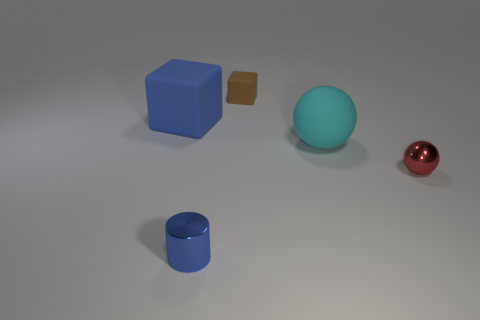Add 5 large purple shiny spheres. How many objects exist? 10 Subtract all balls. How many objects are left? 3 Subtract all blue objects. Subtract all large yellow blocks. How many objects are left? 3 Add 1 tiny objects. How many tiny objects are left? 4 Add 2 tiny yellow rubber balls. How many tiny yellow rubber balls exist? 2 Subtract 0 purple blocks. How many objects are left? 5 Subtract all purple cylinders. Subtract all blue cubes. How many cylinders are left? 1 